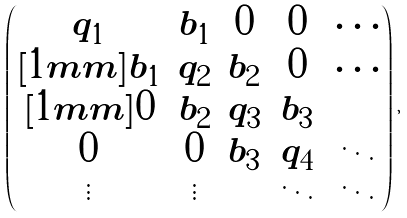Convert formula to latex. <formula><loc_0><loc_0><loc_500><loc_500>\begin{pmatrix} q _ { 1 } & b _ { 1 } & 0 & 0 & \cdots \\ [ 1 m m ] b _ { 1 } & q _ { 2 } & b _ { 2 } & 0 & \cdots \\ [ 1 m m ] 0 & b _ { 2 } & q _ { 3 } & b _ { 3 } & \\ 0 & 0 & b _ { 3 } & q _ { 4 } & \ddots \\ \vdots & \vdots & & \ddots & \ddots \end{pmatrix} \, ,</formula> 